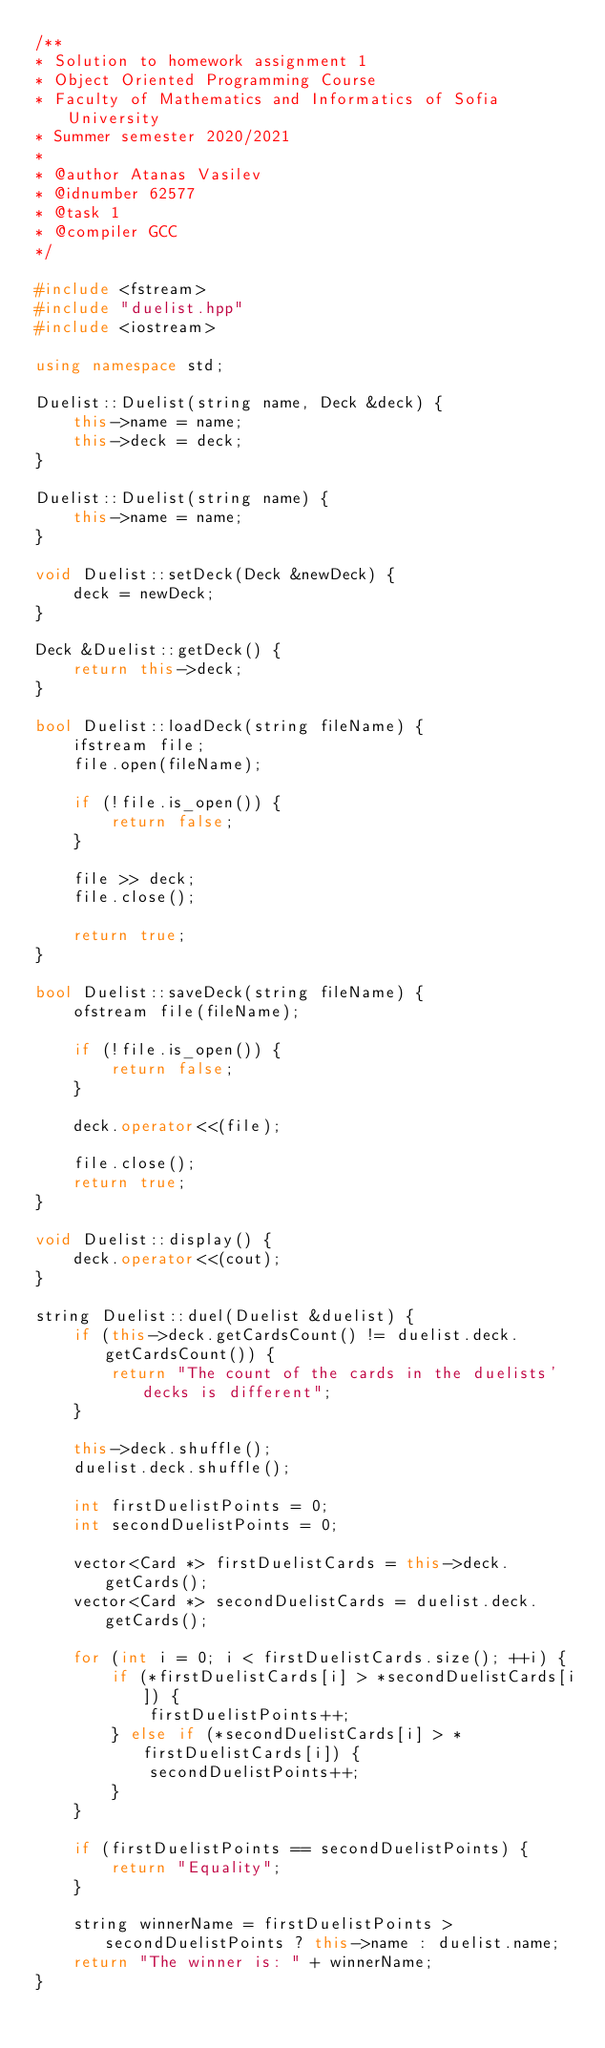<code> <loc_0><loc_0><loc_500><loc_500><_C++_>/**
* Solution to homework assignment 1
* Object Oriented Programming Course
* Faculty of Mathematics and Informatics of Sofia University
* Summer semester 2020/2021
*
* @author Atanas Vasilev
* @idnumber 62577
* @task 1
* @compiler GCC
*/

#include <fstream>
#include "duelist.hpp"
#include <iostream>

using namespace std;

Duelist::Duelist(string name, Deck &deck) {
    this->name = name;
    this->deck = deck;
}

Duelist::Duelist(string name) {
    this->name = name;
}

void Duelist::setDeck(Deck &newDeck) {
    deck = newDeck;
}

Deck &Duelist::getDeck() {
    return this->deck;
}

bool Duelist::loadDeck(string fileName) {
    ifstream file;
    file.open(fileName);

    if (!file.is_open()) {
        return false;
    }

    file >> deck;
    file.close();

    return true;
}

bool Duelist::saveDeck(string fileName) {
    ofstream file(fileName);

    if (!file.is_open()) {
        return false;
    }

    deck.operator<<(file);

    file.close();
    return true;
}

void Duelist::display() {
    deck.operator<<(cout);
}

string Duelist::duel(Duelist &duelist) {
    if (this->deck.getCardsCount() != duelist.deck.getCardsCount()) {
        return "The count of the cards in the duelists' decks is different";
    }

    this->deck.shuffle();
    duelist.deck.shuffle();

    int firstDuelistPoints = 0;
    int secondDuelistPoints = 0;

    vector<Card *> firstDuelistCards = this->deck.getCards();
    vector<Card *> secondDuelistCards = duelist.deck.getCards();

    for (int i = 0; i < firstDuelistCards.size(); ++i) {
        if (*firstDuelistCards[i] > *secondDuelistCards[i]) {
            firstDuelistPoints++;
        } else if (*secondDuelistCards[i] > *firstDuelistCards[i]) {
            secondDuelistPoints++;
        }
    }

    if (firstDuelistPoints == secondDuelistPoints) {
        return "Equality";
    }

    string winnerName = firstDuelistPoints > secondDuelistPoints ? this->name : duelist.name;
    return "The winner is: " + winnerName;
}


</code> 